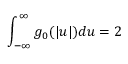Convert formula to latex. <formula><loc_0><loc_0><loc_500><loc_500>\int _ { - \infty } ^ { \infty } g _ { 0 } ( | u | ) d u = 2</formula> 